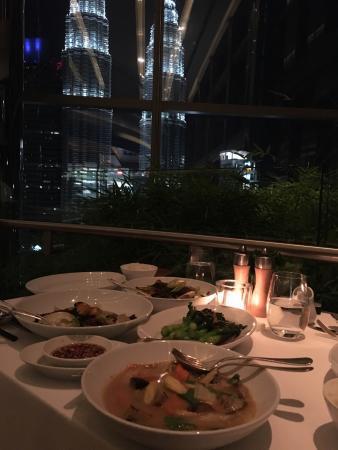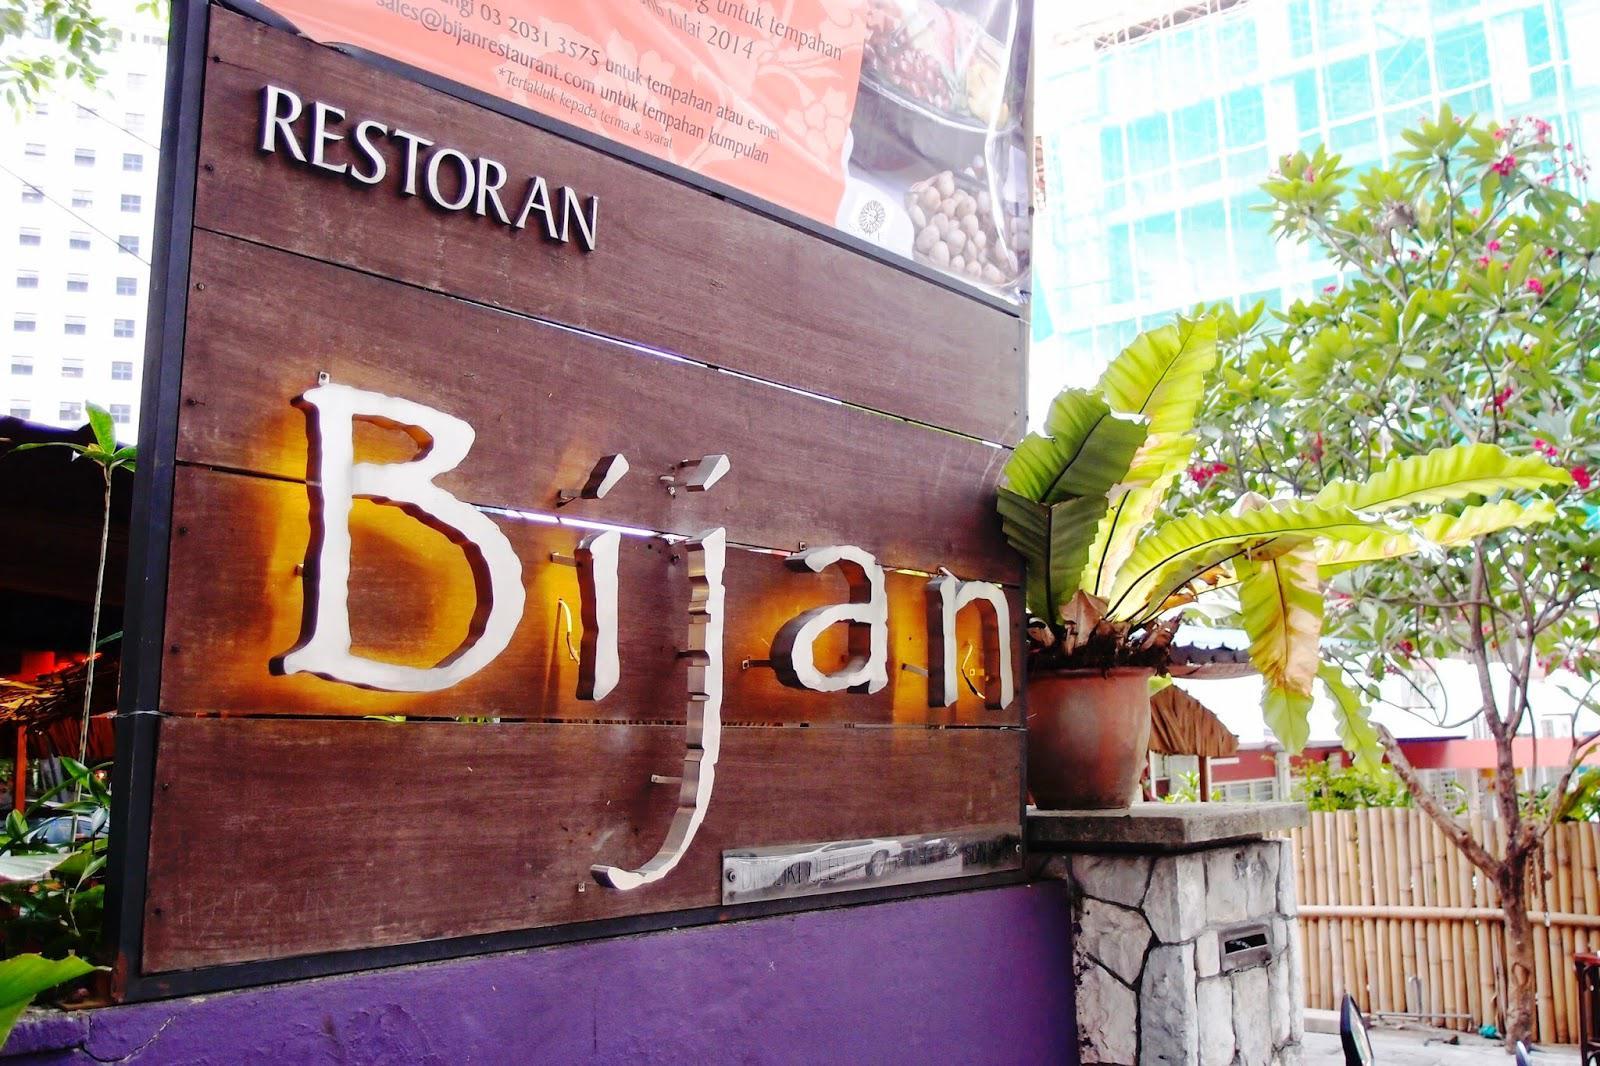The first image is the image on the left, the second image is the image on the right. Analyze the images presented: Is the assertion "At least one photo shows a dining area that is completely lit and also void of guests." valid? Answer yes or no. No. The first image is the image on the left, the second image is the image on the right. For the images displayed, is the sentence "There are at least four round tables with four armless chairs." factually correct? Answer yes or no. No. 